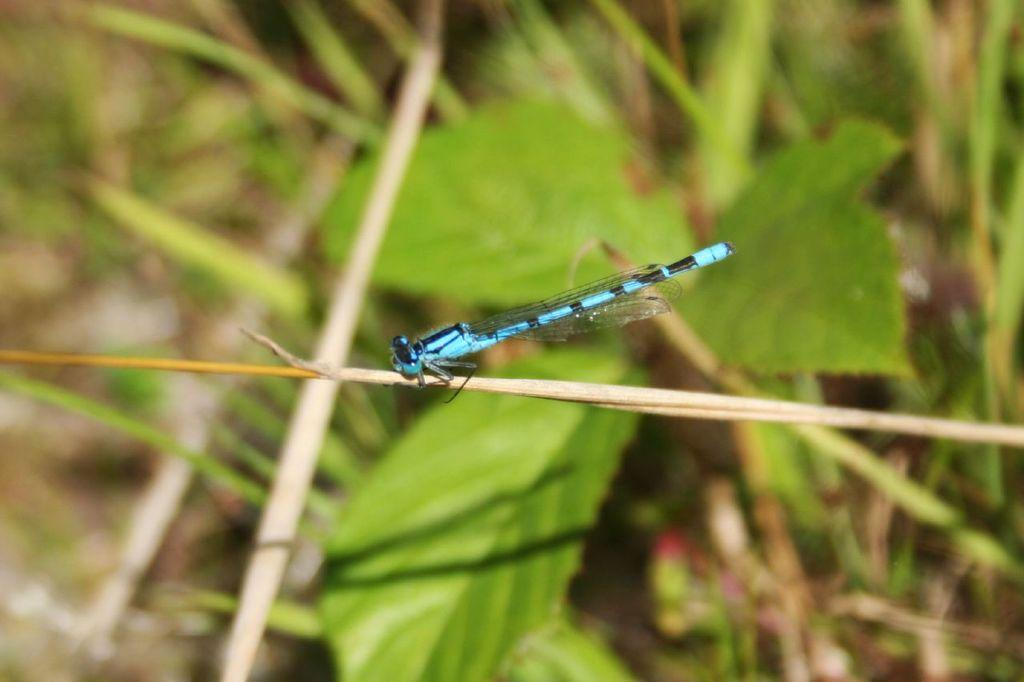What is present on the plant stem in the image? There is an insect on the plant stem in the image. What can be seen in the background of the image? There are leaves visible in the background of the image. What type of crime is being committed by the insect in the image? There is no crime being committed by the insect in the image; it is simply present on the plant stem. 